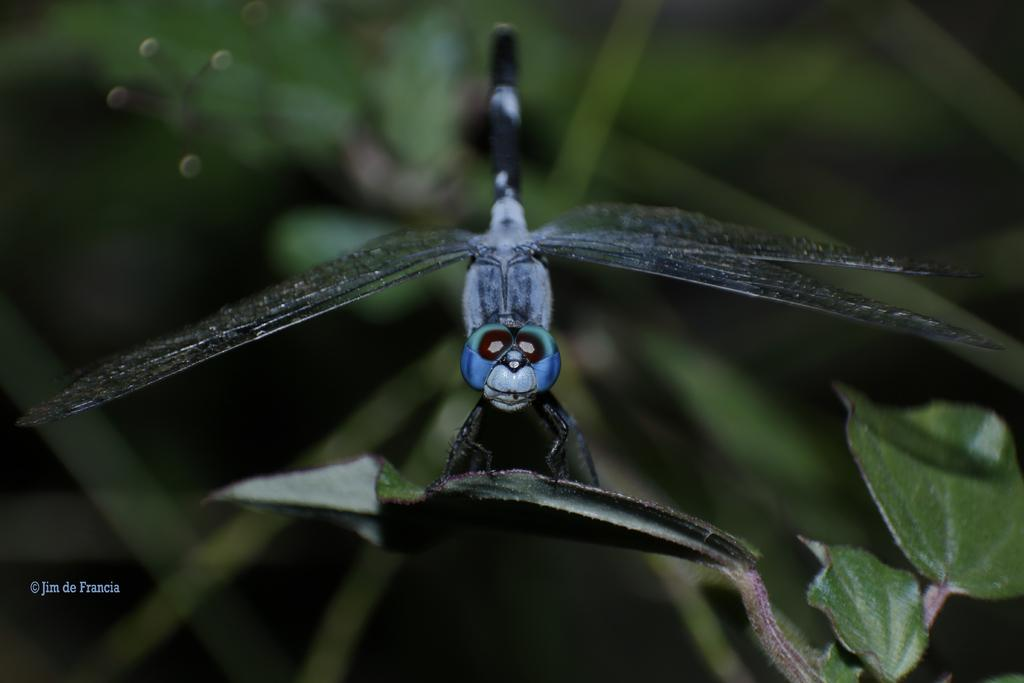What type of creature can be seen in the image? There is an insect in the image. Where is the insect located? The insect is on a leaf. What type of trade is being conducted by the insect in the image? There is no indication of any trade being conducted by the insect in the image. How many houses can be seen in the image? There are no houses present in the image; it features an insect on a leaf. 